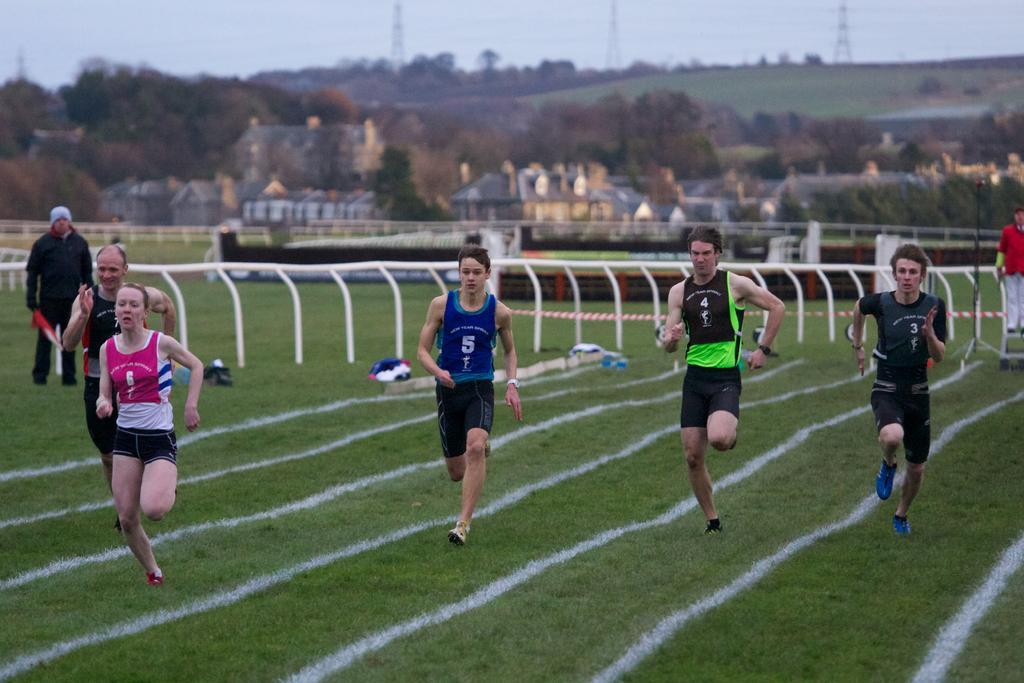Describe this image in one or two sentences. In this image I can see few persons are standing on the ground, some grass on the ground and few lines which are white in color on the ground. In the background I can see few other persons standing, the white colored railing, few buildings, few trees, few towers and the sky. 